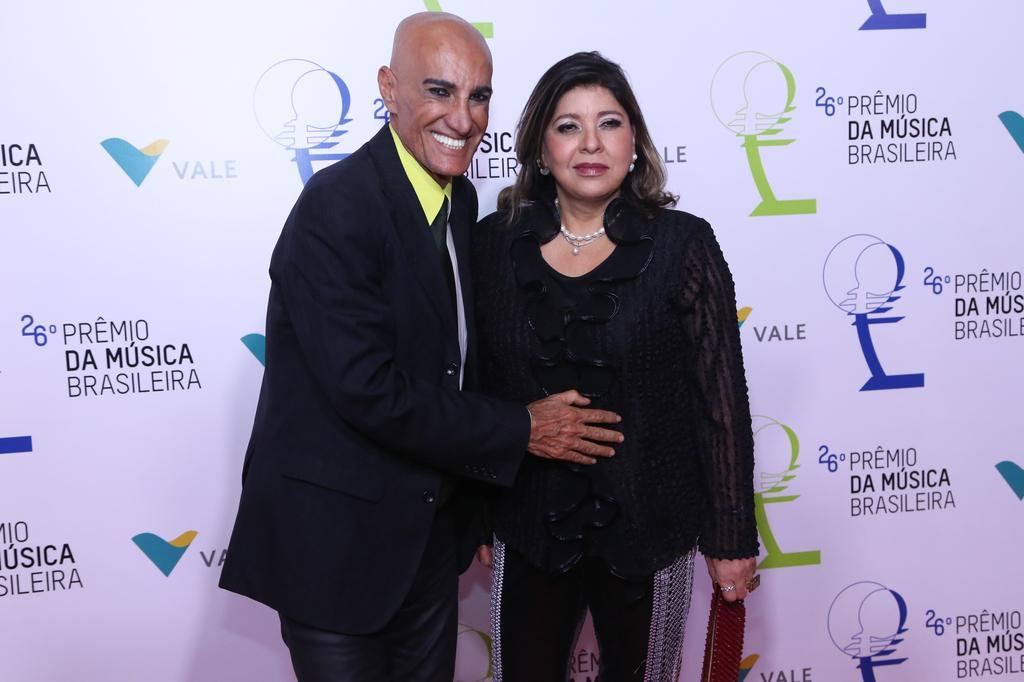Please provide a concise description of this image. In this image there is a couple in the middle. There is a man on the left side who is keeping his hand on the woman who is beside him. In the background there is a banner. The woman is holding the purse. 